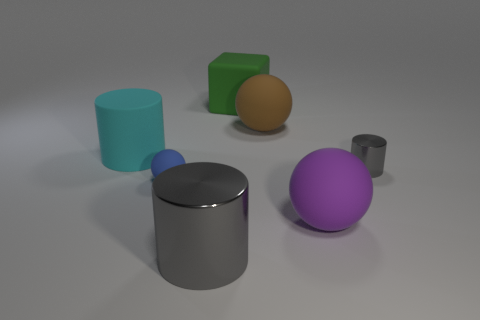Subtract all small gray cylinders. How many cylinders are left? 2 Subtract all blue balls. How many gray cylinders are left? 2 Add 2 tiny brown blocks. How many objects exist? 9 Subtract all cylinders. How many objects are left? 4 Subtract all blue cylinders. Subtract all green balls. How many cylinders are left? 3 Subtract 0 purple blocks. How many objects are left? 7 Subtract all cyan cylinders. Subtract all big brown metal blocks. How many objects are left? 6 Add 6 metallic things. How many metallic things are left? 8 Add 2 small blue spheres. How many small blue spheres exist? 3 